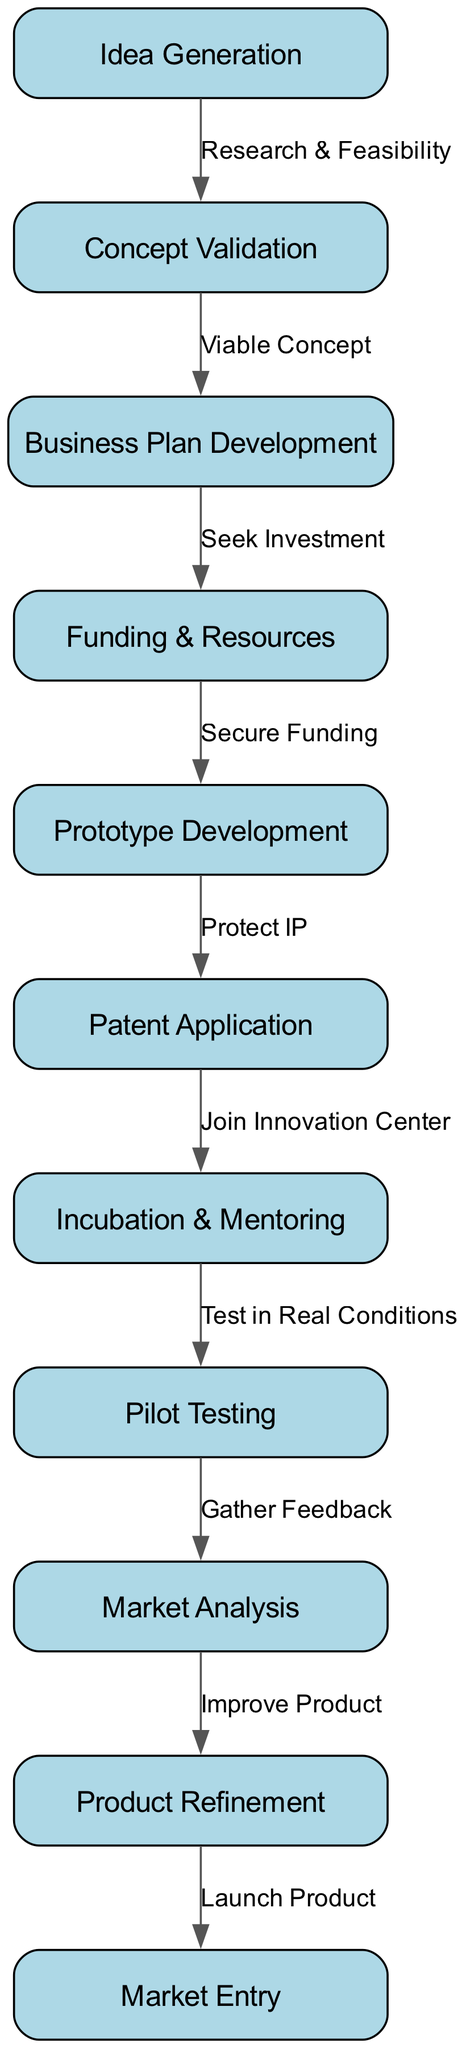What is the first stage in the lifecycle? The first stage in the lifecycle is represented by the node titled "Idea Generation," which is clearly marked as the starting point of the flowchart.
Answer: Idea Generation How many nodes are there in total? By counting each unique stage in the lifecycle shown in the diagram, we find that there are eleven distinct nodes.
Answer: 11 What follows Concept Validation in the flowchart? In the diagram, Concept Validation is directly followed by the node titled "Business Plan Development." This can be confirmed by tracing the directed edge from node 2 to node 3.
Answer: Business Plan Development What is the purpose of the edge from Prototype Development to Patent Application? The edge from Prototype Development to Patent Application is labeled "Protect IP," indicating that the purpose of this step is to secure intellectual property rights following the development of a prototype.
Answer: Protect IP What stage requires gathering feedback? According to the flowchart, the stage that requires gathering feedback is "Pilot Testing," as it precedes the "Market Analysis" stage, which is where the feedback is collected.
Answer: Pilot Testing What action is taken after securing funding? The action taken after securing funding is "Prototype Development," as indicated by the directed edge from the "Funding & Resources" node to the "Prototype Development" node.
Answer: Prototype Development Which stages involve the innovation center? The stages that involve the innovation center are "Patent Application" and "Incubation & Mentoring," as specified by the edge that indicates joining the center after the patent application step.
Answer: Patent Application, Incubation & Mentoring What is the last step in the startup lifecycle? The last step in the startup lifecycle, as depicted in the diagram, is "Market Entry," which is clearly marked as the concluding node of the flowchart.
Answer: Market Entry What do you need to do after gathering feedback? After gathering feedback, the next step is "Product Refinement," which indicates that improvements to the product are made based on the received feedback.
Answer: Product Refinement 